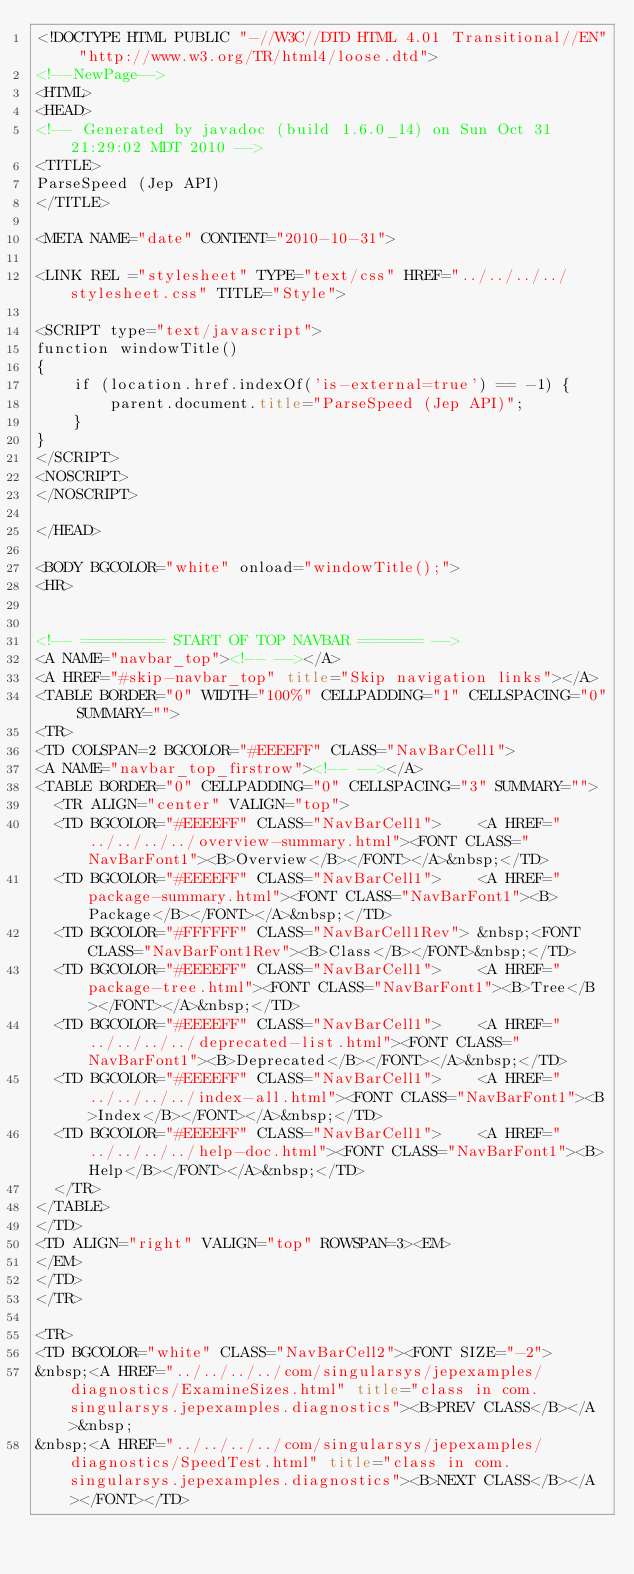Convert code to text. <code><loc_0><loc_0><loc_500><loc_500><_HTML_><!DOCTYPE HTML PUBLIC "-//W3C//DTD HTML 4.01 Transitional//EN" "http://www.w3.org/TR/html4/loose.dtd">
<!--NewPage-->
<HTML>
<HEAD>
<!-- Generated by javadoc (build 1.6.0_14) on Sun Oct 31 21:29:02 MDT 2010 -->
<TITLE>
ParseSpeed (Jep API)
</TITLE>

<META NAME="date" CONTENT="2010-10-31">

<LINK REL ="stylesheet" TYPE="text/css" HREF="../../../../stylesheet.css" TITLE="Style">

<SCRIPT type="text/javascript">
function windowTitle()
{
    if (location.href.indexOf('is-external=true') == -1) {
        parent.document.title="ParseSpeed (Jep API)";
    }
}
</SCRIPT>
<NOSCRIPT>
</NOSCRIPT>

</HEAD>

<BODY BGCOLOR="white" onload="windowTitle();">
<HR>


<!-- ========= START OF TOP NAVBAR ======= -->
<A NAME="navbar_top"><!-- --></A>
<A HREF="#skip-navbar_top" title="Skip navigation links"></A>
<TABLE BORDER="0" WIDTH="100%" CELLPADDING="1" CELLSPACING="0" SUMMARY="">
<TR>
<TD COLSPAN=2 BGCOLOR="#EEEEFF" CLASS="NavBarCell1">
<A NAME="navbar_top_firstrow"><!-- --></A>
<TABLE BORDER="0" CELLPADDING="0" CELLSPACING="3" SUMMARY="">
  <TR ALIGN="center" VALIGN="top">
  <TD BGCOLOR="#EEEEFF" CLASS="NavBarCell1">    <A HREF="../../../../overview-summary.html"><FONT CLASS="NavBarFont1"><B>Overview</B></FONT></A>&nbsp;</TD>
  <TD BGCOLOR="#EEEEFF" CLASS="NavBarCell1">    <A HREF="package-summary.html"><FONT CLASS="NavBarFont1"><B>Package</B></FONT></A>&nbsp;</TD>
  <TD BGCOLOR="#FFFFFF" CLASS="NavBarCell1Rev"> &nbsp;<FONT CLASS="NavBarFont1Rev"><B>Class</B></FONT>&nbsp;</TD>
  <TD BGCOLOR="#EEEEFF" CLASS="NavBarCell1">    <A HREF="package-tree.html"><FONT CLASS="NavBarFont1"><B>Tree</B></FONT></A>&nbsp;</TD>
  <TD BGCOLOR="#EEEEFF" CLASS="NavBarCell1">    <A HREF="../../../../deprecated-list.html"><FONT CLASS="NavBarFont1"><B>Deprecated</B></FONT></A>&nbsp;</TD>
  <TD BGCOLOR="#EEEEFF" CLASS="NavBarCell1">    <A HREF="../../../../index-all.html"><FONT CLASS="NavBarFont1"><B>Index</B></FONT></A>&nbsp;</TD>
  <TD BGCOLOR="#EEEEFF" CLASS="NavBarCell1">    <A HREF="../../../../help-doc.html"><FONT CLASS="NavBarFont1"><B>Help</B></FONT></A>&nbsp;</TD>
  </TR>
</TABLE>
</TD>
<TD ALIGN="right" VALIGN="top" ROWSPAN=3><EM>
</EM>
</TD>
</TR>

<TR>
<TD BGCOLOR="white" CLASS="NavBarCell2"><FONT SIZE="-2">
&nbsp;<A HREF="../../../../com/singularsys/jepexamples/diagnostics/ExamineSizes.html" title="class in com.singularsys.jepexamples.diagnostics"><B>PREV CLASS</B></A>&nbsp;
&nbsp;<A HREF="../../../../com/singularsys/jepexamples/diagnostics/SpeedTest.html" title="class in com.singularsys.jepexamples.diagnostics"><B>NEXT CLASS</B></A></FONT></TD></code> 